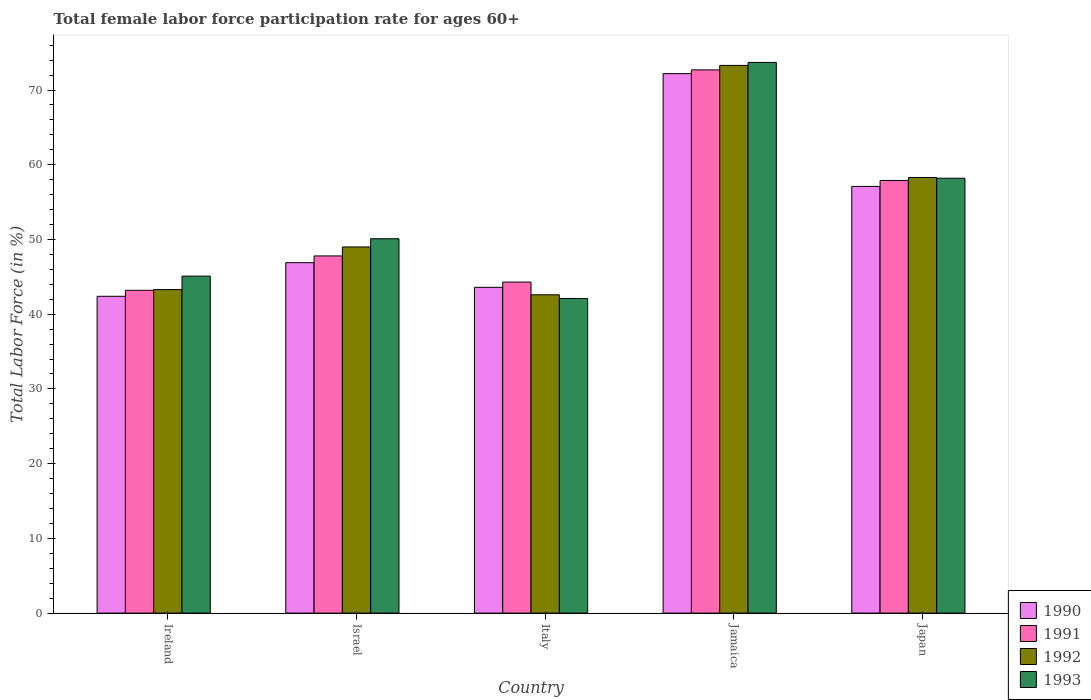Are the number of bars per tick equal to the number of legend labels?
Give a very brief answer. Yes. Are the number of bars on each tick of the X-axis equal?
Ensure brevity in your answer.  Yes. How many bars are there on the 2nd tick from the left?
Provide a succinct answer. 4. What is the label of the 3rd group of bars from the left?
Keep it short and to the point. Italy. In how many cases, is the number of bars for a given country not equal to the number of legend labels?
Keep it short and to the point. 0. What is the female labor force participation rate in 1993 in Japan?
Ensure brevity in your answer.  58.2. Across all countries, what is the maximum female labor force participation rate in 1990?
Offer a very short reply. 72.2. Across all countries, what is the minimum female labor force participation rate in 1992?
Provide a succinct answer. 42.6. In which country was the female labor force participation rate in 1992 maximum?
Provide a short and direct response. Jamaica. What is the total female labor force participation rate in 1991 in the graph?
Ensure brevity in your answer.  265.9. What is the difference between the female labor force participation rate in 1991 in Israel and that in Jamaica?
Your answer should be compact. -24.9. What is the difference between the female labor force participation rate in 1993 in Ireland and the female labor force participation rate in 1990 in Jamaica?
Offer a terse response. -27.1. What is the average female labor force participation rate in 1993 per country?
Your answer should be very brief. 53.84. What is the difference between the female labor force participation rate of/in 1991 and female labor force participation rate of/in 1993 in Jamaica?
Your response must be concise. -1. In how many countries, is the female labor force participation rate in 1992 greater than 2 %?
Ensure brevity in your answer.  5. What is the ratio of the female labor force participation rate in 1991 in Ireland to that in Israel?
Your answer should be very brief. 0.9. Is the female labor force participation rate in 1990 in Ireland less than that in Israel?
Your answer should be compact. Yes. Is the difference between the female labor force participation rate in 1991 in Ireland and Japan greater than the difference between the female labor force participation rate in 1993 in Ireland and Japan?
Give a very brief answer. No. What is the difference between the highest and the second highest female labor force participation rate in 1993?
Your response must be concise. 15.5. What is the difference between the highest and the lowest female labor force participation rate in 1990?
Offer a very short reply. 29.8. Is the sum of the female labor force participation rate in 1992 in Ireland and Japan greater than the maximum female labor force participation rate in 1991 across all countries?
Provide a short and direct response. Yes. What does the 4th bar from the right in Japan represents?
Provide a short and direct response. 1990. How many bars are there?
Your answer should be compact. 20. Are all the bars in the graph horizontal?
Provide a succinct answer. No. Are the values on the major ticks of Y-axis written in scientific E-notation?
Keep it short and to the point. No. Does the graph contain any zero values?
Keep it short and to the point. No. How many legend labels are there?
Keep it short and to the point. 4. What is the title of the graph?
Give a very brief answer. Total female labor force participation rate for ages 60+. Does "1961" appear as one of the legend labels in the graph?
Offer a terse response. No. What is the label or title of the X-axis?
Offer a terse response. Country. What is the label or title of the Y-axis?
Make the answer very short. Total Labor Force (in %). What is the Total Labor Force (in %) of 1990 in Ireland?
Provide a succinct answer. 42.4. What is the Total Labor Force (in %) in 1991 in Ireland?
Offer a very short reply. 43.2. What is the Total Labor Force (in %) of 1992 in Ireland?
Offer a very short reply. 43.3. What is the Total Labor Force (in %) in 1993 in Ireland?
Provide a short and direct response. 45.1. What is the Total Labor Force (in %) of 1990 in Israel?
Give a very brief answer. 46.9. What is the Total Labor Force (in %) of 1991 in Israel?
Offer a very short reply. 47.8. What is the Total Labor Force (in %) in 1993 in Israel?
Your response must be concise. 50.1. What is the Total Labor Force (in %) in 1990 in Italy?
Your response must be concise. 43.6. What is the Total Labor Force (in %) of 1991 in Italy?
Offer a terse response. 44.3. What is the Total Labor Force (in %) in 1992 in Italy?
Your answer should be compact. 42.6. What is the Total Labor Force (in %) of 1993 in Italy?
Your answer should be compact. 42.1. What is the Total Labor Force (in %) of 1990 in Jamaica?
Give a very brief answer. 72.2. What is the Total Labor Force (in %) in 1991 in Jamaica?
Provide a short and direct response. 72.7. What is the Total Labor Force (in %) of 1992 in Jamaica?
Provide a succinct answer. 73.3. What is the Total Labor Force (in %) in 1993 in Jamaica?
Your answer should be compact. 73.7. What is the Total Labor Force (in %) in 1990 in Japan?
Make the answer very short. 57.1. What is the Total Labor Force (in %) in 1991 in Japan?
Your answer should be very brief. 57.9. What is the Total Labor Force (in %) of 1992 in Japan?
Ensure brevity in your answer.  58.3. What is the Total Labor Force (in %) in 1993 in Japan?
Keep it short and to the point. 58.2. Across all countries, what is the maximum Total Labor Force (in %) of 1990?
Your answer should be very brief. 72.2. Across all countries, what is the maximum Total Labor Force (in %) of 1991?
Keep it short and to the point. 72.7. Across all countries, what is the maximum Total Labor Force (in %) in 1992?
Give a very brief answer. 73.3. Across all countries, what is the maximum Total Labor Force (in %) of 1993?
Provide a short and direct response. 73.7. Across all countries, what is the minimum Total Labor Force (in %) in 1990?
Provide a succinct answer. 42.4. Across all countries, what is the minimum Total Labor Force (in %) in 1991?
Provide a succinct answer. 43.2. Across all countries, what is the minimum Total Labor Force (in %) in 1992?
Offer a terse response. 42.6. Across all countries, what is the minimum Total Labor Force (in %) in 1993?
Give a very brief answer. 42.1. What is the total Total Labor Force (in %) of 1990 in the graph?
Offer a very short reply. 262.2. What is the total Total Labor Force (in %) in 1991 in the graph?
Offer a terse response. 265.9. What is the total Total Labor Force (in %) of 1992 in the graph?
Offer a very short reply. 266.5. What is the total Total Labor Force (in %) of 1993 in the graph?
Make the answer very short. 269.2. What is the difference between the Total Labor Force (in %) in 1990 in Ireland and that in Israel?
Offer a very short reply. -4.5. What is the difference between the Total Labor Force (in %) of 1991 in Ireland and that in Israel?
Your response must be concise. -4.6. What is the difference between the Total Labor Force (in %) of 1993 in Ireland and that in Israel?
Make the answer very short. -5. What is the difference between the Total Labor Force (in %) in 1993 in Ireland and that in Italy?
Offer a terse response. 3. What is the difference between the Total Labor Force (in %) of 1990 in Ireland and that in Jamaica?
Provide a succinct answer. -29.8. What is the difference between the Total Labor Force (in %) in 1991 in Ireland and that in Jamaica?
Your answer should be very brief. -29.5. What is the difference between the Total Labor Force (in %) of 1993 in Ireland and that in Jamaica?
Your response must be concise. -28.6. What is the difference between the Total Labor Force (in %) of 1990 in Ireland and that in Japan?
Provide a succinct answer. -14.7. What is the difference between the Total Labor Force (in %) of 1991 in Ireland and that in Japan?
Your answer should be compact. -14.7. What is the difference between the Total Labor Force (in %) in 1991 in Israel and that in Italy?
Offer a very short reply. 3.5. What is the difference between the Total Labor Force (in %) of 1993 in Israel and that in Italy?
Your answer should be very brief. 8. What is the difference between the Total Labor Force (in %) in 1990 in Israel and that in Jamaica?
Make the answer very short. -25.3. What is the difference between the Total Labor Force (in %) of 1991 in Israel and that in Jamaica?
Give a very brief answer. -24.9. What is the difference between the Total Labor Force (in %) of 1992 in Israel and that in Jamaica?
Your response must be concise. -24.3. What is the difference between the Total Labor Force (in %) of 1993 in Israel and that in Jamaica?
Offer a terse response. -23.6. What is the difference between the Total Labor Force (in %) of 1990 in Israel and that in Japan?
Provide a succinct answer. -10.2. What is the difference between the Total Labor Force (in %) in 1993 in Israel and that in Japan?
Provide a short and direct response. -8.1. What is the difference between the Total Labor Force (in %) of 1990 in Italy and that in Jamaica?
Your answer should be very brief. -28.6. What is the difference between the Total Labor Force (in %) in 1991 in Italy and that in Jamaica?
Your response must be concise. -28.4. What is the difference between the Total Labor Force (in %) in 1992 in Italy and that in Jamaica?
Provide a short and direct response. -30.7. What is the difference between the Total Labor Force (in %) of 1993 in Italy and that in Jamaica?
Your answer should be very brief. -31.6. What is the difference between the Total Labor Force (in %) in 1990 in Italy and that in Japan?
Your response must be concise. -13.5. What is the difference between the Total Labor Force (in %) of 1991 in Italy and that in Japan?
Give a very brief answer. -13.6. What is the difference between the Total Labor Force (in %) in 1992 in Italy and that in Japan?
Offer a very short reply. -15.7. What is the difference between the Total Labor Force (in %) in 1993 in Italy and that in Japan?
Provide a short and direct response. -16.1. What is the difference between the Total Labor Force (in %) in 1991 in Jamaica and that in Japan?
Make the answer very short. 14.8. What is the difference between the Total Labor Force (in %) in 1992 in Jamaica and that in Japan?
Your answer should be very brief. 15. What is the difference between the Total Labor Force (in %) of 1990 in Ireland and the Total Labor Force (in %) of 1991 in Israel?
Offer a terse response. -5.4. What is the difference between the Total Labor Force (in %) in 1990 in Ireland and the Total Labor Force (in %) in 1993 in Israel?
Provide a succinct answer. -7.7. What is the difference between the Total Labor Force (in %) of 1991 in Ireland and the Total Labor Force (in %) of 1992 in Israel?
Ensure brevity in your answer.  -5.8. What is the difference between the Total Labor Force (in %) of 1991 in Ireland and the Total Labor Force (in %) of 1993 in Israel?
Ensure brevity in your answer.  -6.9. What is the difference between the Total Labor Force (in %) in 1992 in Ireland and the Total Labor Force (in %) in 1993 in Israel?
Keep it short and to the point. -6.8. What is the difference between the Total Labor Force (in %) of 1990 in Ireland and the Total Labor Force (in %) of 1991 in Italy?
Ensure brevity in your answer.  -1.9. What is the difference between the Total Labor Force (in %) of 1990 in Ireland and the Total Labor Force (in %) of 1992 in Italy?
Your response must be concise. -0.2. What is the difference between the Total Labor Force (in %) in 1990 in Ireland and the Total Labor Force (in %) in 1991 in Jamaica?
Offer a terse response. -30.3. What is the difference between the Total Labor Force (in %) in 1990 in Ireland and the Total Labor Force (in %) in 1992 in Jamaica?
Ensure brevity in your answer.  -30.9. What is the difference between the Total Labor Force (in %) in 1990 in Ireland and the Total Labor Force (in %) in 1993 in Jamaica?
Ensure brevity in your answer.  -31.3. What is the difference between the Total Labor Force (in %) in 1991 in Ireland and the Total Labor Force (in %) in 1992 in Jamaica?
Keep it short and to the point. -30.1. What is the difference between the Total Labor Force (in %) of 1991 in Ireland and the Total Labor Force (in %) of 1993 in Jamaica?
Offer a very short reply. -30.5. What is the difference between the Total Labor Force (in %) in 1992 in Ireland and the Total Labor Force (in %) in 1993 in Jamaica?
Ensure brevity in your answer.  -30.4. What is the difference between the Total Labor Force (in %) of 1990 in Ireland and the Total Labor Force (in %) of 1991 in Japan?
Your response must be concise. -15.5. What is the difference between the Total Labor Force (in %) of 1990 in Ireland and the Total Labor Force (in %) of 1992 in Japan?
Keep it short and to the point. -15.9. What is the difference between the Total Labor Force (in %) of 1990 in Ireland and the Total Labor Force (in %) of 1993 in Japan?
Offer a very short reply. -15.8. What is the difference between the Total Labor Force (in %) in 1991 in Ireland and the Total Labor Force (in %) in 1992 in Japan?
Provide a short and direct response. -15.1. What is the difference between the Total Labor Force (in %) of 1992 in Ireland and the Total Labor Force (in %) of 1993 in Japan?
Your answer should be very brief. -14.9. What is the difference between the Total Labor Force (in %) in 1990 in Israel and the Total Labor Force (in %) in 1991 in Jamaica?
Provide a succinct answer. -25.8. What is the difference between the Total Labor Force (in %) in 1990 in Israel and the Total Labor Force (in %) in 1992 in Jamaica?
Offer a very short reply. -26.4. What is the difference between the Total Labor Force (in %) of 1990 in Israel and the Total Labor Force (in %) of 1993 in Jamaica?
Provide a succinct answer. -26.8. What is the difference between the Total Labor Force (in %) of 1991 in Israel and the Total Labor Force (in %) of 1992 in Jamaica?
Your answer should be very brief. -25.5. What is the difference between the Total Labor Force (in %) of 1991 in Israel and the Total Labor Force (in %) of 1993 in Jamaica?
Provide a short and direct response. -25.9. What is the difference between the Total Labor Force (in %) of 1992 in Israel and the Total Labor Force (in %) of 1993 in Jamaica?
Make the answer very short. -24.7. What is the difference between the Total Labor Force (in %) in 1990 in Israel and the Total Labor Force (in %) in 1991 in Japan?
Provide a short and direct response. -11. What is the difference between the Total Labor Force (in %) of 1990 in Israel and the Total Labor Force (in %) of 1992 in Japan?
Give a very brief answer. -11.4. What is the difference between the Total Labor Force (in %) in 1990 in Israel and the Total Labor Force (in %) in 1993 in Japan?
Your answer should be compact. -11.3. What is the difference between the Total Labor Force (in %) of 1991 in Israel and the Total Labor Force (in %) of 1992 in Japan?
Offer a very short reply. -10.5. What is the difference between the Total Labor Force (in %) in 1991 in Israel and the Total Labor Force (in %) in 1993 in Japan?
Keep it short and to the point. -10.4. What is the difference between the Total Labor Force (in %) of 1992 in Israel and the Total Labor Force (in %) of 1993 in Japan?
Provide a succinct answer. -9.2. What is the difference between the Total Labor Force (in %) of 1990 in Italy and the Total Labor Force (in %) of 1991 in Jamaica?
Provide a short and direct response. -29.1. What is the difference between the Total Labor Force (in %) of 1990 in Italy and the Total Labor Force (in %) of 1992 in Jamaica?
Provide a succinct answer. -29.7. What is the difference between the Total Labor Force (in %) in 1990 in Italy and the Total Labor Force (in %) in 1993 in Jamaica?
Make the answer very short. -30.1. What is the difference between the Total Labor Force (in %) of 1991 in Italy and the Total Labor Force (in %) of 1993 in Jamaica?
Provide a succinct answer. -29.4. What is the difference between the Total Labor Force (in %) of 1992 in Italy and the Total Labor Force (in %) of 1993 in Jamaica?
Your answer should be compact. -31.1. What is the difference between the Total Labor Force (in %) in 1990 in Italy and the Total Labor Force (in %) in 1991 in Japan?
Offer a very short reply. -14.3. What is the difference between the Total Labor Force (in %) of 1990 in Italy and the Total Labor Force (in %) of 1992 in Japan?
Ensure brevity in your answer.  -14.7. What is the difference between the Total Labor Force (in %) in 1990 in Italy and the Total Labor Force (in %) in 1993 in Japan?
Offer a very short reply. -14.6. What is the difference between the Total Labor Force (in %) in 1991 in Italy and the Total Labor Force (in %) in 1993 in Japan?
Your answer should be very brief. -13.9. What is the difference between the Total Labor Force (in %) of 1992 in Italy and the Total Labor Force (in %) of 1993 in Japan?
Ensure brevity in your answer.  -15.6. What is the difference between the Total Labor Force (in %) of 1990 in Jamaica and the Total Labor Force (in %) of 1992 in Japan?
Make the answer very short. 13.9. What is the difference between the Total Labor Force (in %) of 1990 in Jamaica and the Total Labor Force (in %) of 1993 in Japan?
Provide a short and direct response. 14. What is the difference between the Total Labor Force (in %) of 1991 in Jamaica and the Total Labor Force (in %) of 1992 in Japan?
Provide a short and direct response. 14.4. What is the difference between the Total Labor Force (in %) of 1992 in Jamaica and the Total Labor Force (in %) of 1993 in Japan?
Your response must be concise. 15.1. What is the average Total Labor Force (in %) in 1990 per country?
Provide a short and direct response. 52.44. What is the average Total Labor Force (in %) of 1991 per country?
Give a very brief answer. 53.18. What is the average Total Labor Force (in %) in 1992 per country?
Your answer should be very brief. 53.3. What is the average Total Labor Force (in %) of 1993 per country?
Provide a short and direct response. 53.84. What is the difference between the Total Labor Force (in %) of 1990 and Total Labor Force (in %) of 1992 in Ireland?
Ensure brevity in your answer.  -0.9. What is the difference between the Total Labor Force (in %) in 1990 and Total Labor Force (in %) in 1993 in Ireland?
Your response must be concise. -2.7. What is the difference between the Total Labor Force (in %) in 1992 and Total Labor Force (in %) in 1993 in Ireland?
Provide a short and direct response. -1.8. What is the difference between the Total Labor Force (in %) in 1990 and Total Labor Force (in %) in 1991 in Israel?
Provide a short and direct response. -0.9. What is the difference between the Total Labor Force (in %) in 1991 and Total Labor Force (in %) in 1992 in Israel?
Ensure brevity in your answer.  -1.2. What is the difference between the Total Labor Force (in %) in 1992 and Total Labor Force (in %) in 1993 in Israel?
Offer a terse response. -1.1. What is the difference between the Total Labor Force (in %) in 1990 and Total Labor Force (in %) in 1992 in Italy?
Make the answer very short. 1. What is the difference between the Total Labor Force (in %) in 1990 and Total Labor Force (in %) in 1993 in Italy?
Offer a very short reply. 1.5. What is the difference between the Total Labor Force (in %) of 1991 and Total Labor Force (in %) of 1992 in Italy?
Provide a succinct answer. 1.7. What is the difference between the Total Labor Force (in %) in 1991 and Total Labor Force (in %) in 1993 in Italy?
Give a very brief answer. 2.2. What is the difference between the Total Labor Force (in %) of 1992 and Total Labor Force (in %) of 1993 in Italy?
Your response must be concise. 0.5. What is the difference between the Total Labor Force (in %) of 1990 and Total Labor Force (in %) of 1991 in Jamaica?
Make the answer very short. -0.5. What is the difference between the Total Labor Force (in %) in 1990 and Total Labor Force (in %) in 1992 in Jamaica?
Your answer should be compact. -1.1. What is the difference between the Total Labor Force (in %) of 1990 and Total Labor Force (in %) of 1993 in Jamaica?
Ensure brevity in your answer.  -1.5. What is the difference between the Total Labor Force (in %) of 1991 and Total Labor Force (in %) of 1992 in Jamaica?
Keep it short and to the point. -0.6. What is the difference between the Total Labor Force (in %) in 1991 and Total Labor Force (in %) in 1993 in Jamaica?
Give a very brief answer. -1. What is the difference between the Total Labor Force (in %) of 1992 and Total Labor Force (in %) of 1993 in Jamaica?
Make the answer very short. -0.4. What is the difference between the Total Labor Force (in %) in 1992 and Total Labor Force (in %) in 1993 in Japan?
Keep it short and to the point. 0.1. What is the ratio of the Total Labor Force (in %) of 1990 in Ireland to that in Israel?
Ensure brevity in your answer.  0.9. What is the ratio of the Total Labor Force (in %) in 1991 in Ireland to that in Israel?
Offer a terse response. 0.9. What is the ratio of the Total Labor Force (in %) in 1992 in Ireland to that in Israel?
Keep it short and to the point. 0.88. What is the ratio of the Total Labor Force (in %) in 1993 in Ireland to that in Israel?
Ensure brevity in your answer.  0.9. What is the ratio of the Total Labor Force (in %) of 1990 in Ireland to that in Italy?
Provide a succinct answer. 0.97. What is the ratio of the Total Labor Force (in %) in 1991 in Ireland to that in Italy?
Make the answer very short. 0.98. What is the ratio of the Total Labor Force (in %) of 1992 in Ireland to that in Italy?
Offer a very short reply. 1.02. What is the ratio of the Total Labor Force (in %) of 1993 in Ireland to that in Italy?
Keep it short and to the point. 1.07. What is the ratio of the Total Labor Force (in %) in 1990 in Ireland to that in Jamaica?
Your response must be concise. 0.59. What is the ratio of the Total Labor Force (in %) of 1991 in Ireland to that in Jamaica?
Provide a short and direct response. 0.59. What is the ratio of the Total Labor Force (in %) in 1992 in Ireland to that in Jamaica?
Provide a short and direct response. 0.59. What is the ratio of the Total Labor Force (in %) in 1993 in Ireland to that in Jamaica?
Offer a very short reply. 0.61. What is the ratio of the Total Labor Force (in %) in 1990 in Ireland to that in Japan?
Keep it short and to the point. 0.74. What is the ratio of the Total Labor Force (in %) of 1991 in Ireland to that in Japan?
Keep it short and to the point. 0.75. What is the ratio of the Total Labor Force (in %) of 1992 in Ireland to that in Japan?
Give a very brief answer. 0.74. What is the ratio of the Total Labor Force (in %) in 1993 in Ireland to that in Japan?
Provide a succinct answer. 0.77. What is the ratio of the Total Labor Force (in %) in 1990 in Israel to that in Italy?
Give a very brief answer. 1.08. What is the ratio of the Total Labor Force (in %) in 1991 in Israel to that in Italy?
Offer a terse response. 1.08. What is the ratio of the Total Labor Force (in %) of 1992 in Israel to that in Italy?
Offer a terse response. 1.15. What is the ratio of the Total Labor Force (in %) of 1993 in Israel to that in Italy?
Provide a short and direct response. 1.19. What is the ratio of the Total Labor Force (in %) of 1990 in Israel to that in Jamaica?
Provide a short and direct response. 0.65. What is the ratio of the Total Labor Force (in %) of 1991 in Israel to that in Jamaica?
Provide a succinct answer. 0.66. What is the ratio of the Total Labor Force (in %) in 1992 in Israel to that in Jamaica?
Provide a short and direct response. 0.67. What is the ratio of the Total Labor Force (in %) of 1993 in Israel to that in Jamaica?
Make the answer very short. 0.68. What is the ratio of the Total Labor Force (in %) in 1990 in Israel to that in Japan?
Keep it short and to the point. 0.82. What is the ratio of the Total Labor Force (in %) of 1991 in Israel to that in Japan?
Ensure brevity in your answer.  0.83. What is the ratio of the Total Labor Force (in %) in 1992 in Israel to that in Japan?
Provide a succinct answer. 0.84. What is the ratio of the Total Labor Force (in %) in 1993 in Israel to that in Japan?
Provide a short and direct response. 0.86. What is the ratio of the Total Labor Force (in %) in 1990 in Italy to that in Jamaica?
Provide a succinct answer. 0.6. What is the ratio of the Total Labor Force (in %) of 1991 in Italy to that in Jamaica?
Your answer should be compact. 0.61. What is the ratio of the Total Labor Force (in %) in 1992 in Italy to that in Jamaica?
Offer a very short reply. 0.58. What is the ratio of the Total Labor Force (in %) in 1993 in Italy to that in Jamaica?
Ensure brevity in your answer.  0.57. What is the ratio of the Total Labor Force (in %) in 1990 in Italy to that in Japan?
Keep it short and to the point. 0.76. What is the ratio of the Total Labor Force (in %) in 1991 in Italy to that in Japan?
Keep it short and to the point. 0.77. What is the ratio of the Total Labor Force (in %) of 1992 in Italy to that in Japan?
Provide a short and direct response. 0.73. What is the ratio of the Total Labor Force (in %) of 1993 in Italy to that in Japan?
Provide a short and direct response. 0.72. What is the ratio of the Total Labor Force (in %) in 1990 in Jamaica to that in Japan?
Your answer should be compact. 1.26. What is the ratio of the Total Labor Force (in %) in 1991 in Jamaica to that in Japan?
Offer a very short reply. 1.26. What is the ratio of the Total Labor Force (in %) of 1992 in Jamaica to that in Japan?
Give a very brief answer. 1.26. What is the ratio of the Total Labor Force (in %) of 1993 in Jamaica to that in Japan?
Your answer should be very brief. 1.27. What is the difference between the highest and the second highest Total Labor Force (in %) of 1990?
Keep it short and to the point. 15.1. What is the difference between the highest and the second highest Total Labor Force (in %) in 1991?
Give a very brief answer. 14.8. What is the difference between the highest and the lowest Total Labor Force (in %) of 1990?
Provide a short and direct response. 29.8. What is the difference between the highest and the lowest Total Labor Force (in %) of 1991?
Your response must be concise. 29.5. What is the difference between the highest and the lowest Total Labor Force (in %) of 1992?
Provide a succinct answer. 30.7. What is the difference between the highest and the lowest Total Labor Force (in %) in 1993?
Your response must be concise. 31.6. 